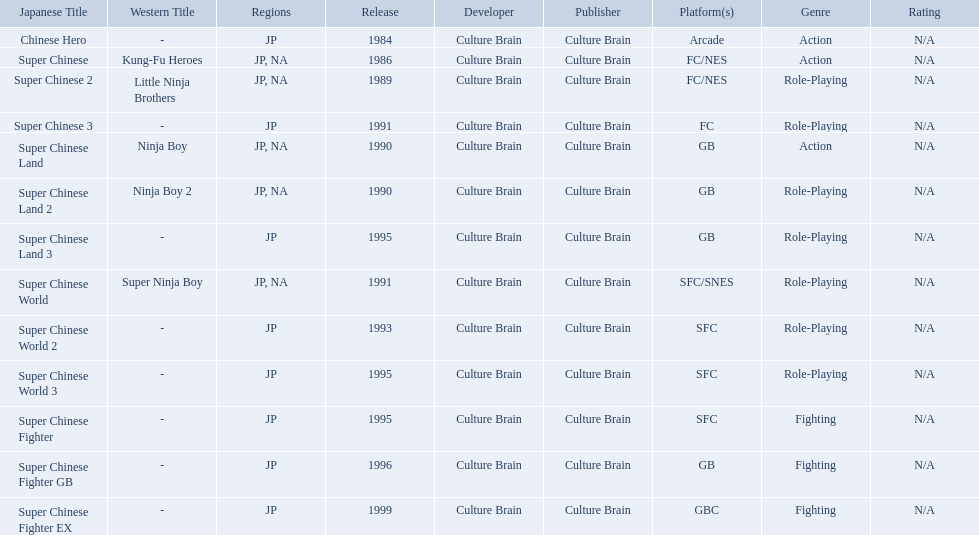Which titles were released in north america? Super Chinese, Super Chinese 2, Super Chinese Land, Super Chinese Land 2, Super Chinese World. Of those, which had the least releases? Super Chinese World. 